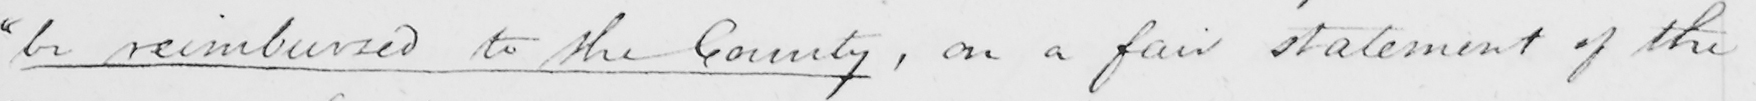Transcribe the text shown in this historical manuscript line. " be reimbursed to the County , on a fair statement of the 